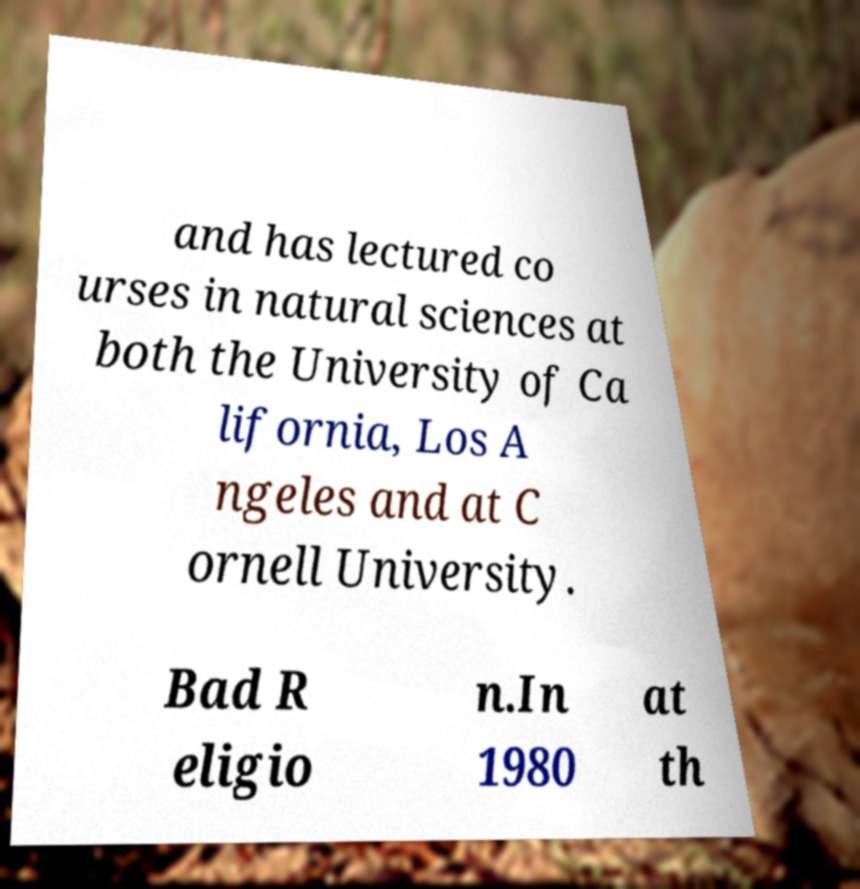What messages or text are displayed in this image? I need them in a readable, typed format. and has lectured co urses in natural sciences at both the University of Ca lifornia, Los A ngeles and at C ornell University. Bad R eligio n.In 1980 at th 